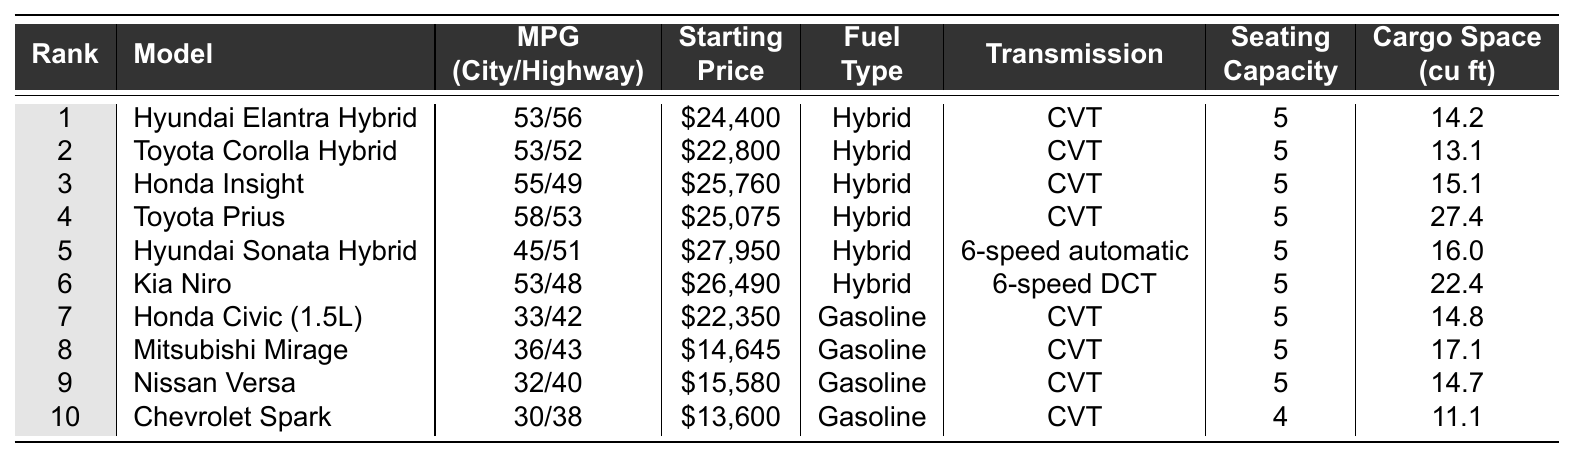What is the most fuel-efficient car on the list? The table indicates that the Toyota Prius has the highest fuel efficiency, with a city/highway rating of 58/53 MPG.
Answer: Toyota Prius Which car has the lowest starting price? By examining the starting prices in the table, the Chevrolet Spark is priced at $13,600, making it the least expensive option listed.
Answer: Chevrolet Spark Is the Hyundai Sonata Hybrid more fuel-efficient than the Honda Civic (1.5L)? The Hyundai Sonata Hybrid has a fuel efficiency of 45/51 MPG, while the Honda Civic has 33/42 MPG, so the Sonata is indeed more fuel-efficient.
Answer: Yes What is the average seating capacity of the cars listed? The total seating capacity noted in the table is (5 + 5 + 5 + 5 + 5 + 5 + 5 + 5 + 5 + 4) = 49, and there are 10 cars, so the average seating capacity is 49/10 = 4.9.
Answer: 4.9 How many hybrid cars are in the top 10 list? The table displays seven hybrid cars: Hyundai Elantra Hybrid, Toyota Corolla Hybrid, Honda Insight, Toyota Prius, Hyundai Sonata Hybrid, Kia Niro.
Answer: 6 What is the difference in cargo space between the Toyota Prius and the Mitsubishi Mirage? The Toyota Prius offers 27.4 cu ft of cargo space, while the Mitsubishi Mirage has 17.1 cu ft. Thus, the difference is 27.4 - 17.1 = 10.3 cu ft.
Answer: 10.3 cu ft Which car has the highest fuel efficiency in the city? Looking at the city MPG, the Toyota Prius has the highest rating at 58 MPG.
Answer: Toyota Prius Is there a gasoline car that has better fuel efficiency than the Hyundai Sonata Hybrid? The Hyundai Sonata Hybrid rates at 45/51 MPG, while the best gasoline option, the Honda Civic (1.5L), has a city/highway rating of 33/42 MPG, meaning no gasoline car is more efficient.
Answer: No What is the total starting price of the top three cars? The starting prices for the top three vehicles are $24,400 + $22,800 + $25,760 = $73,960.
Answer: $73,960 Which model has a higher highway MPG: Kia Niro or Hyundai Elantra Hybrid? The Kia Niro has a highway MPG of 48, while the Hyundai Elantra Hybrid has 56. Since 56 > 48, the Elantra is more efficient on the highway.
Answer: Hyundai Elantra Hybrid 